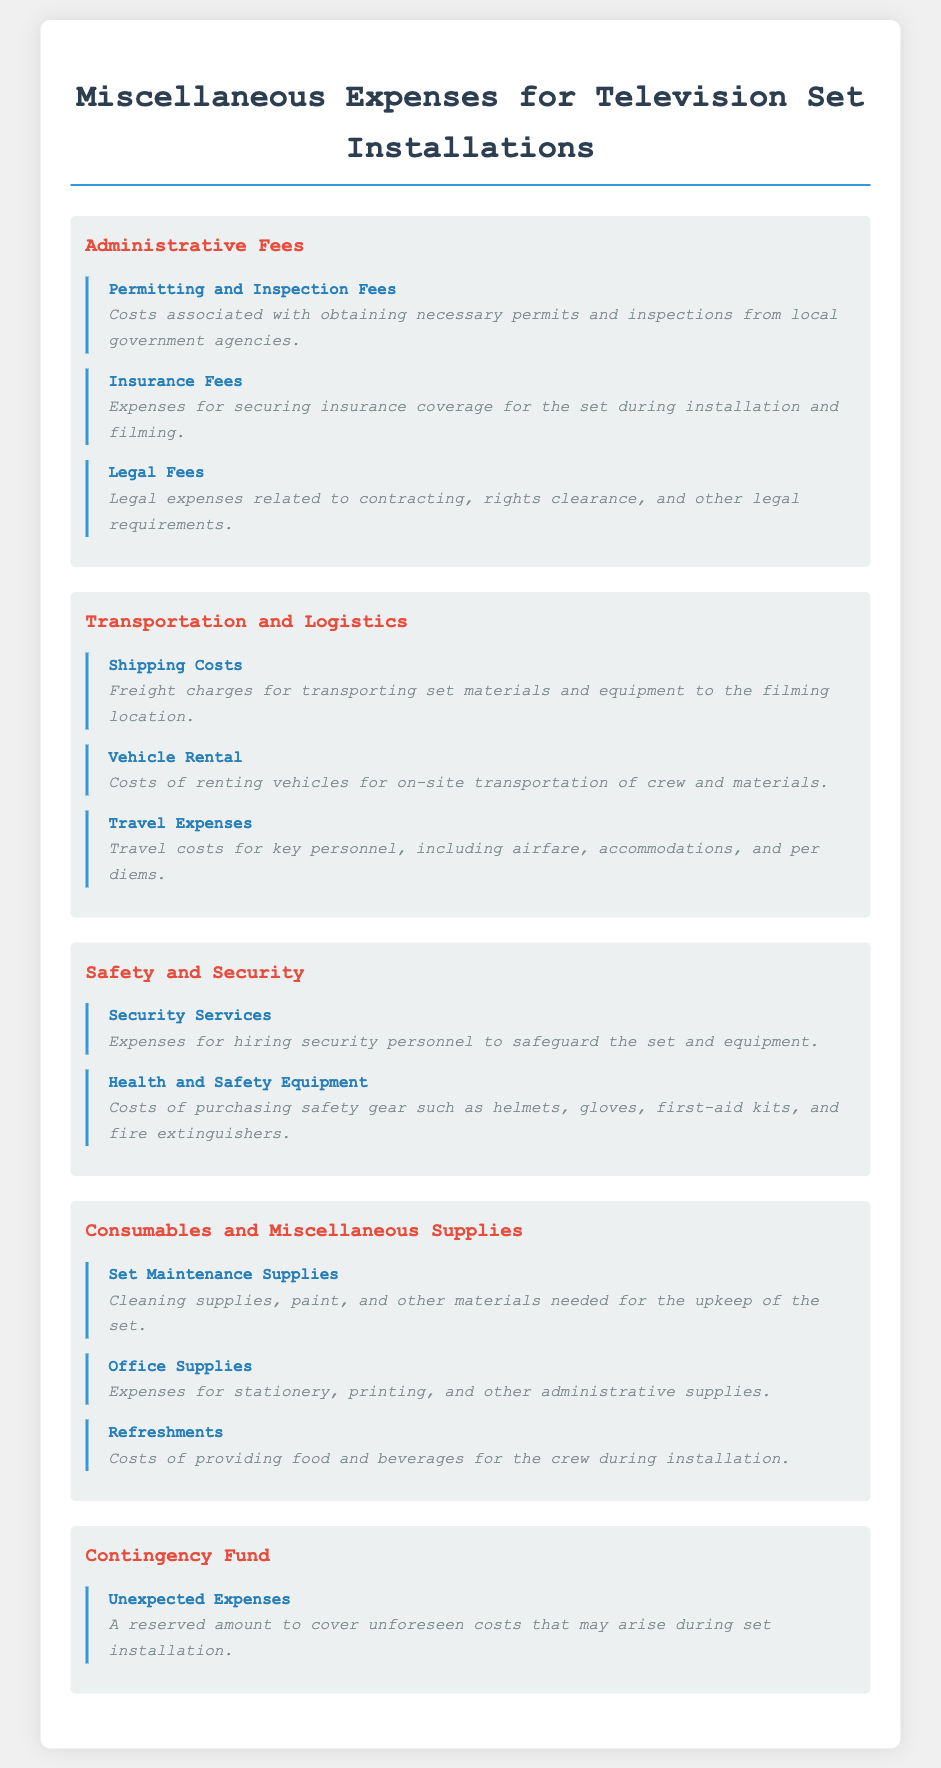What are the types of administrative fees? The document lists three types of administrative fees: Permitting and Inspection Fees, Insurance Fees, and Legal Fees.
Answer: Permitting and Inspection Fees, Insurance Fees, Legal Fees What is included in transportation and logistics expenses? The document details three items related to transportation and logistics: Shipping Costs, Vehicle Rental, and Travel Expenses.
Answer: Shipping Costs, Vehicle Rental, Travel Expenses What kind of equipment does the health and safety category include? The document mentions the need for purchasing safety gear such as helmets, gloves, first-aid kits, and fire extinguishers under health and safety equipment.
Answer: Helmets, gloves, first-aid kits, fire extinguishers What is the purpose of the contingency fund? The document states that the contingency fund is reserved for covering unforeseen costs that may arise during set installation.
Answer: Unexpected Expenses How many categories are there in the document? The document organizes miscellaneous expenses into five categories: Administrative Fees, Transportation and Logistics, Safety and Security, Consumables and Miscellaneous Supplies, and Contingency Fund.
Answer: Five categories 